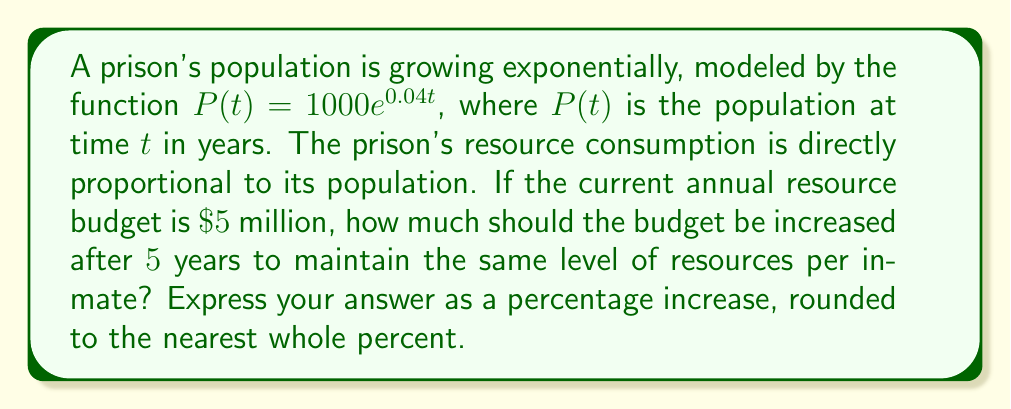What is the answer to this math problem? To solve this problem, we'll follow these steps:

1) First, we need to calculate the growth factor of the prison population over 5 years.

   The original function is $P(t) = 1000e^{0.04t}$
   After 5 years, $t = 5$, so:
   $P(5) = 1000e^{0.04(5)} = 1000e^{0.2}$

2) The growth factor is:
   $$\frac{P(5)}{P(0)} = \frac{1000e^{0.2}}{1000} = e^{0.2} \approx 1.2214$$

3) This means the population (and thus the required resources) will increase by a factor of approximately 1.2214 over 5 years.

4) To maintain the same level of resources per inmate, the budget must increase by the same factor.

5) If the current budget is $\$5$ million, the new budget should be:
   $$5,000,000 \times 1.2214 = \$6,107,000$$

6) To calculate the percentage increase:
   $$\text{Percentage increase} = \frac{\text{Increase}}{\text{Original}} \times 100\%$$
   $$= \frac{6,107,000 - 5,000,000}{5,000,000} \times 100\%$$
   $$= \frac{1,107,000}{5,000,000} \times 100\% \approx 22.14\%$$

7) Rounding to the nearest whole percent gives us 22%.
Answer: The budget should be increased by 22% after 5 years. 